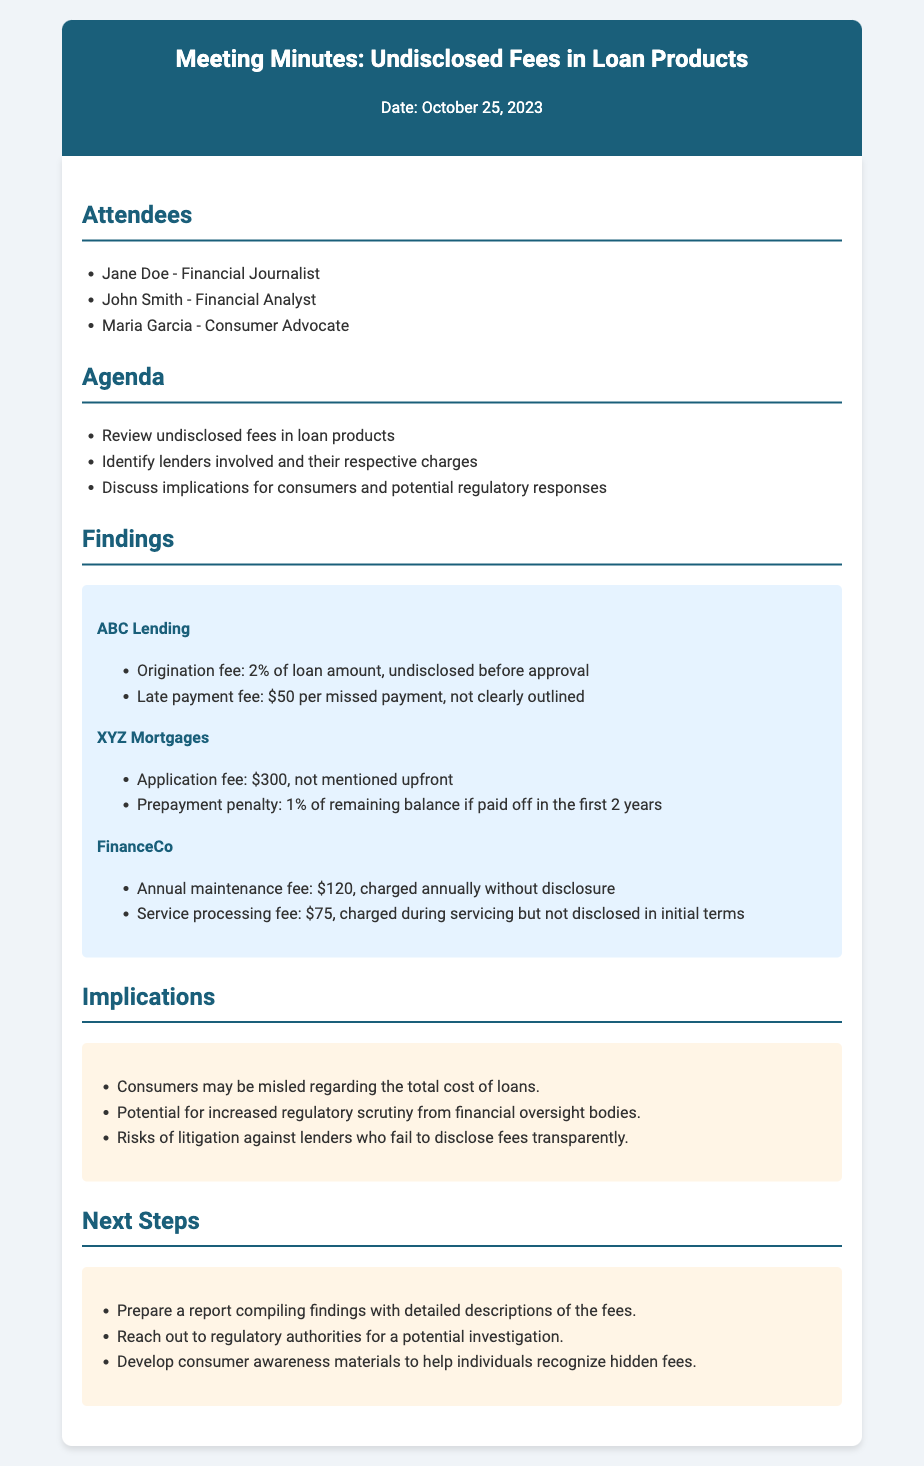What is the date of the meeting? The date of the meeting is explicitly stated in the header of the document.
Answer: October 25, 2023 Who is the financial analyst that attended the meeting? The name of the financial analyst is listed in the attendees section of the document.
Answer: John Smith What is the application fee charged by XYZ Mortgages? The application fee for XYZ Mortgages is mentioned in the findings section of the document.
Answer: $300 What undisclosed fee does ABC Lending charge for missed payments? The specific fee related to missed payments for ABC Lending is detailed in the findings section.
Answer: $50 per missed payment How much is the annual maintenance fee charged by FinanceCo? The amount for the annual maintenance fee by FinanceCo is clearly outlined in the findings section.
Answer: $120 What is one potential implication of undisclosed fees for consumers? One of the implications is listed in the implications section, highlighting consumer risks.
Answer: Misled regarding the total cost of loans What next step involves regulatory authorities? The next step that mentions regulatory authorities is found in the next steps section of the document.
Answer: Reach out to regulatory authorities for a potential investigation How many attendees were present at the meeting? The number of attendees can be counted from the attendees section in the document.
Answer: 3 